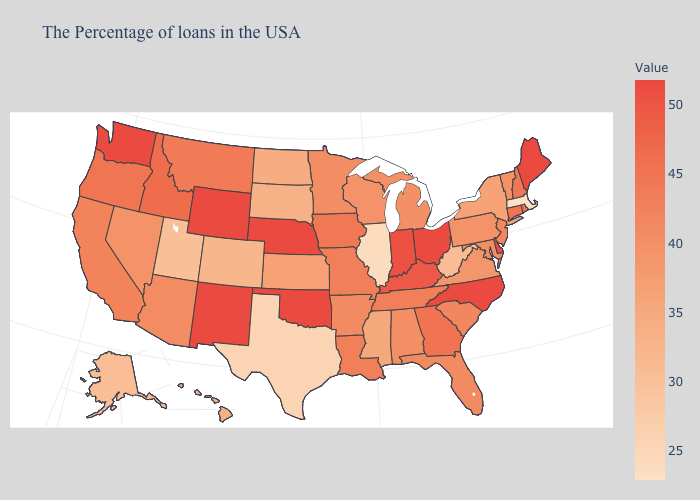Among the states that border Utah , does Idaho have the highest value?
Be succinct. No. Does the map have missing data?
Answer briefly. No. Which states hav the highest value in the South?
Quick response, please. Delaware, North Carolina, Oklahoma. Among the states that border Kentucky , does Tennessee have the lowest value?
Keep it brief. No. Does the map have missing data?
Quick response, please. No. Among the states that border Nebraska , does Missouri have the lowest value?
Write a very short answer. No. Among the states that border Kentucky , does Indiana have the lowest value?
Give a very brief answer. No. Is the legend a continuous bar?
Write a very short answer. Yes. Among the states that border Tennessee , does Virginia have the highest value?
Give a very brief answer. No. 